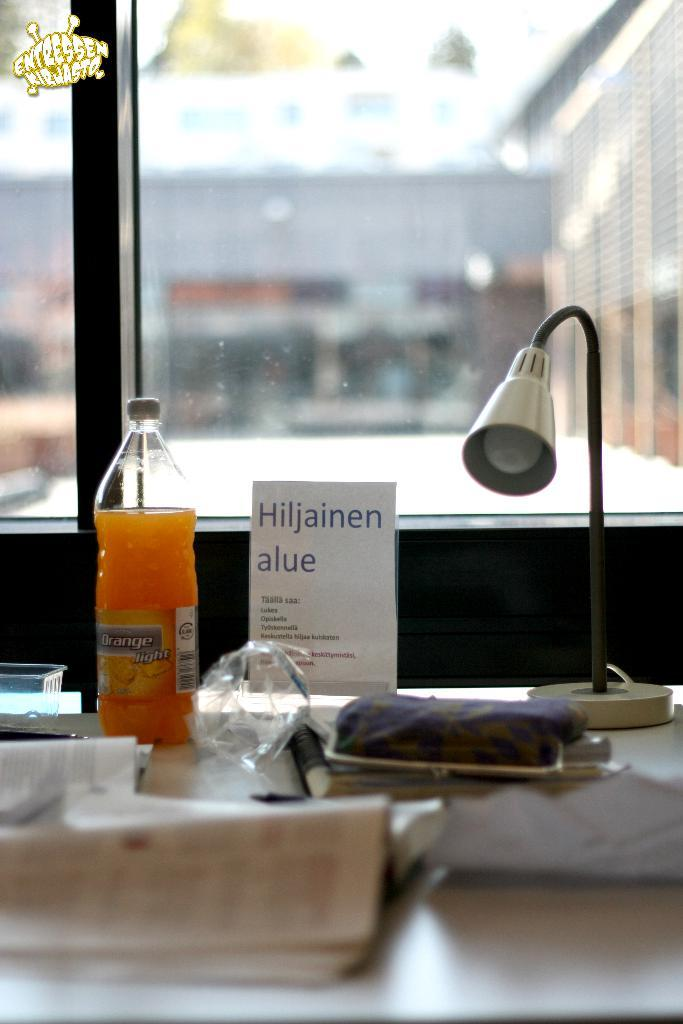What objects are on the table in the image? There is a bottle, a lamp, a wallet, books, and a board on the table in the image. What can be seen through the glass window? A building is visible through the glass window. What type of window is present in the image? There is a glass window in the image. What type of quartz is present on the table in the image? There is no quartz present on the table in the image. What type of war is depicted in the image? There is no war depicted in the image; it features a table with various objects and a building visible through a glass window. 